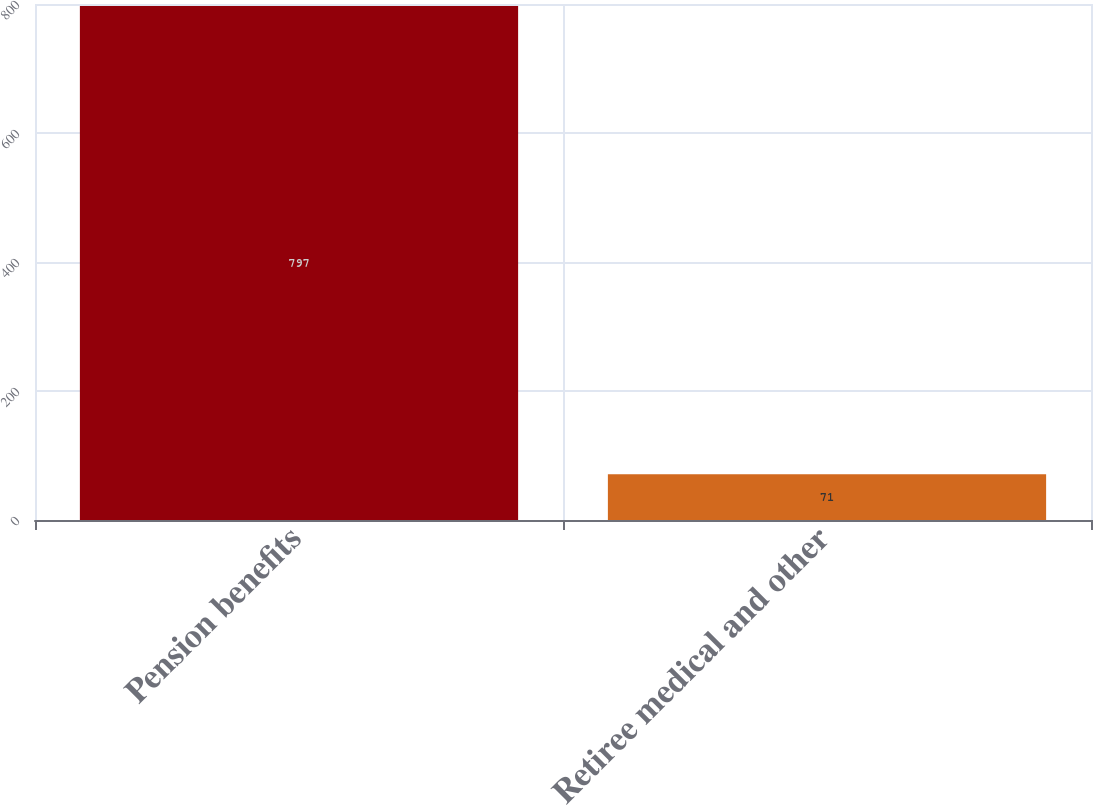Convert chart. <chart><loc_0><loc_0><loc_500><loc_500><bar_chart><fcel>Pension benefits<fcel>Retiree medical and other<nl><fcel>797<fcel>71<nl></chart> 